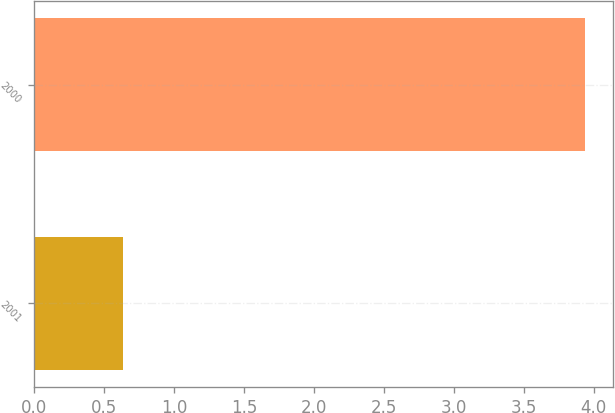<chart> <loc_0><loc_0><loc_500><loc_500><bar_chart><fcel>2001<fcel>2000<nl><fcel>0.63<fcel>3.94<nl></chart> 